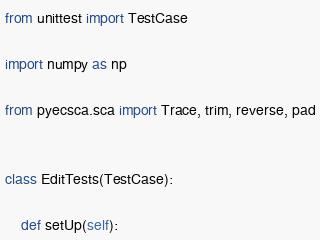<code> <loc_0><loc_0><loc_500><loc_500><_Python_>from unittest import TestCase

import numpy as np

from pyecsca.sca import Trace, trim, reverse, pad


class EditTests(TestCase):

    def setUp(self):</code> 